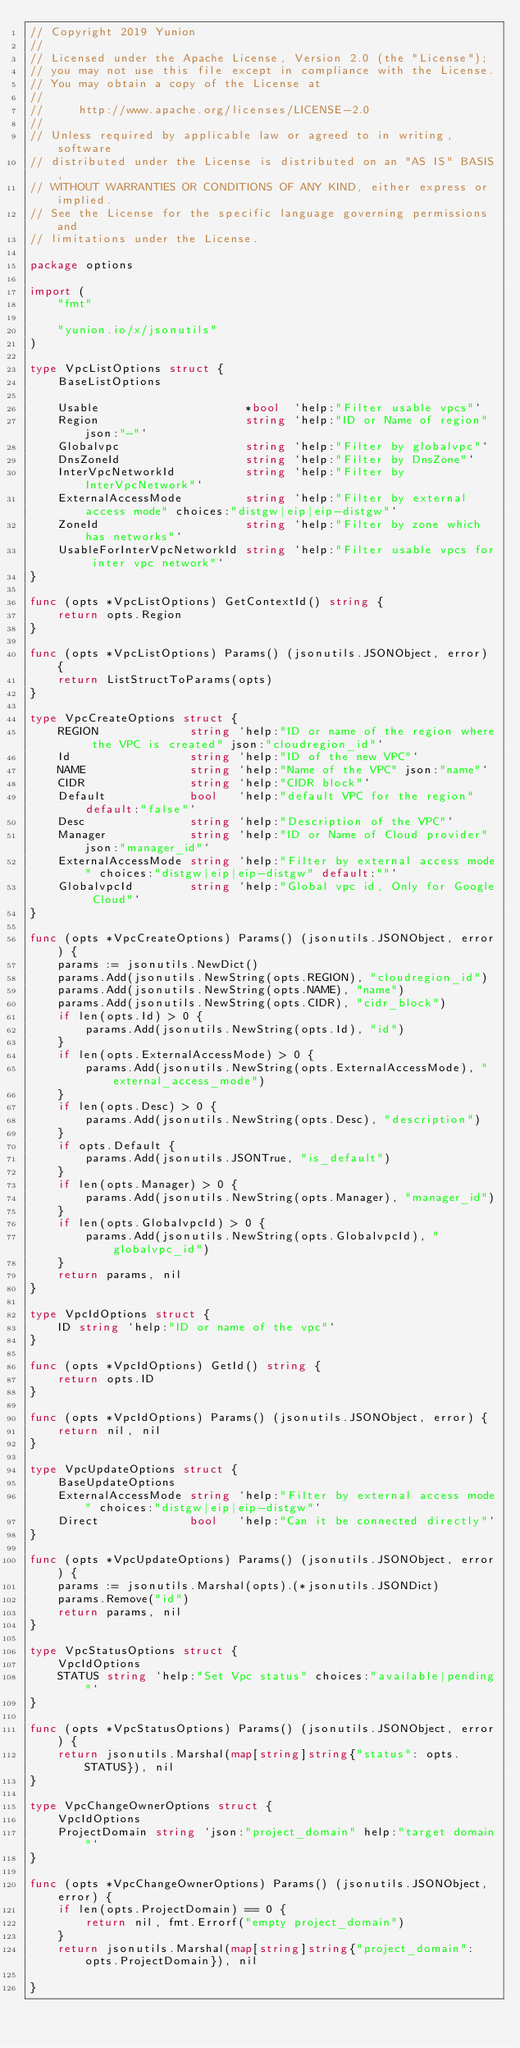<code> <loc_0><loc_0><loc_500><loc_500><_Go_>// Copyright 2019 Yunion
//
// Licensed under the Apache License, Version 2.0 (the "License");
// you may not use this file except in compliance with the License.
// You may obtain a copy of the License at
//
//     http://www.apache.org/licenses/LICENSE-2.0
//
// Unless required by applicable law or agreed to in writing, software
// distributed under the License is distributed on an "AS IS" BASIS,
// WITHOUT WARRANTIES OR CONDITIONS OF ANY KIND, either express or implied.
// See the License for the specific language governing permissions and
// limitations under the License.

package options

import (
	"fmt"

	"yunion.io/x/jsonutils"
)

type VpcListOptions struct {
	BaseListOptions

	Usable                     *bool  `help:"Filter usable vpcs"`
	Region                     string `help:"ID or Name of region" json:"-"`
	Globalvpc                  string `help:"Filter by globalvpc"`
	DnsZoneId                  string `help:"Filter by DnsZone"`
	InterVpcNetworkId          string `help:"Filter by InterVpcNetwork"`
	ExternalAccessMode         string `help:"Filter by external access mode" choices:"distgw|eip|eip-distgw"`
	ZoneId                     string `help:"Filter by zone which has networks"`
	UsableForInterVpcNetworkId string `help:"Filter usable vpcs for inter vpc network"`
}

func (opts *VpcListOptions) GetContextId() string {
	return opts.Region
}

func (opts *VpcListOptions) Params() (jsonutils.JSONObject, error) {
	return ListStructToParams(opts)
}

type VpcCreateOptions struct {
	REGION             string `help:"ID or name of the region where the VPC is created" json:"cloudregion_id"`
	Id                 string `help:"ID of the new VPC"`
	NAME               string `help:"Name of the VPC" json:"name"`
	CIDR               string `help:"CIDR block"`
	Default            bool   `help:"default VPC for the region" default:"false"`
	Desc               string `help:"Description of the VPC"`
	Manager            string `help:"ID or Name of Cloud provider" json:"manager_id"`
	ExternalAccessMode string `help:"Filter by external access mode" choices:"distgw|eip|eip-distgw" default:""`
	GlobalvpcId        string `help:"Global vpc id, Only for Google Cloud"`
}

func (opts *VpcCreateOptions) Params() (jsonutils.JSONObject, error) {
	params := jsonutils.NewDict()
	params.Add(jsonutils.NewString(opts.REGION), "cloudregion_id")
	params.Add(jsonutils.NewString(opts.NAME), "name")
	params.Add(jsonutils.NewString(opts.CIDR), "cidr_block")
	if len(opts.Id) > 0 {
		params.Add(jsonutils.NewString(opts.Id), "id")
	}
	if len(opts.ExternalAccessMode) > 0 {
		params.Add(jsonutils.NewString(opts.ExternalAccessMode), "external_access_mode")
	}
	if len(opts.Desc) > 0 {
		params.Add(jsonutils.NewString(opts.Desc), "description")
	}
	if opts.Default {
		params.Add(jsonutils.JSONTrue, "is_default")
	}
	if len(opts.Manager) > 0 {
		params.Add(jsonutils.NewString(opts.Manager), "manager_id")
	}
	if len(opts.GlobalvpcId) > 0 {
		params.Add(jsonutils.NewString(opts.GlobalvpcId), "globalvpc_id")
	}
	return params, nil
}

type VpcIdOptions struct {
	ID string `help:"ID or name of the vpc"`
}

func (opts *VpcIdOptions) GetId() string {
	return opts.ID
}

func (opts *VpcIdOptions) Params() (jsonutils.JSONObject, error) {
	return nil, nil
}

type VpcUpdateOptions struct {
	BaseUpdateOptions
	ExternalAccessMode string `help:"Filter by external access mode" choices:"distgw|eip|eip-distgw"`
	Direct             bool   `help:"Can it be connected directly"`
}

func (opts *VpcUpdateOptions) Params() (jsonutils.JSONObject, error) {
	params := jsonutils.Marshal(opts).(*jsonutils.JSONDict)
	params.Remove("id")
	return params, nil
}

type VpcStatusOptions struct {
	VpcIdOptions
	STATUS string `help:"Set Vpc status" choices:"available|pending"`
}

func (opts *VpcStatusOptions) Params() (jsonutils.JSONObject, error) {
	return jsonutils.Marshal(map[string]string{"status": opts.STATUS}), nil
}

type VpcChangeOwnerOptions struct {
	VpcIdOptions
	ProjectDomain string `json:"project_domain" help:"target domain"`
}

func (opts *VpcChangeOwnerOptions) Params() (jsonutils.JSONObject, error) {
	if len(opts.ProjectDomain) == 0 {
		return nil, fmt.Errorf("empty project_domain")
	}
	return jsonutils.Marshal(map[string]string{"project_domain": opts.ProjectDomain}), nil

}
</code> 